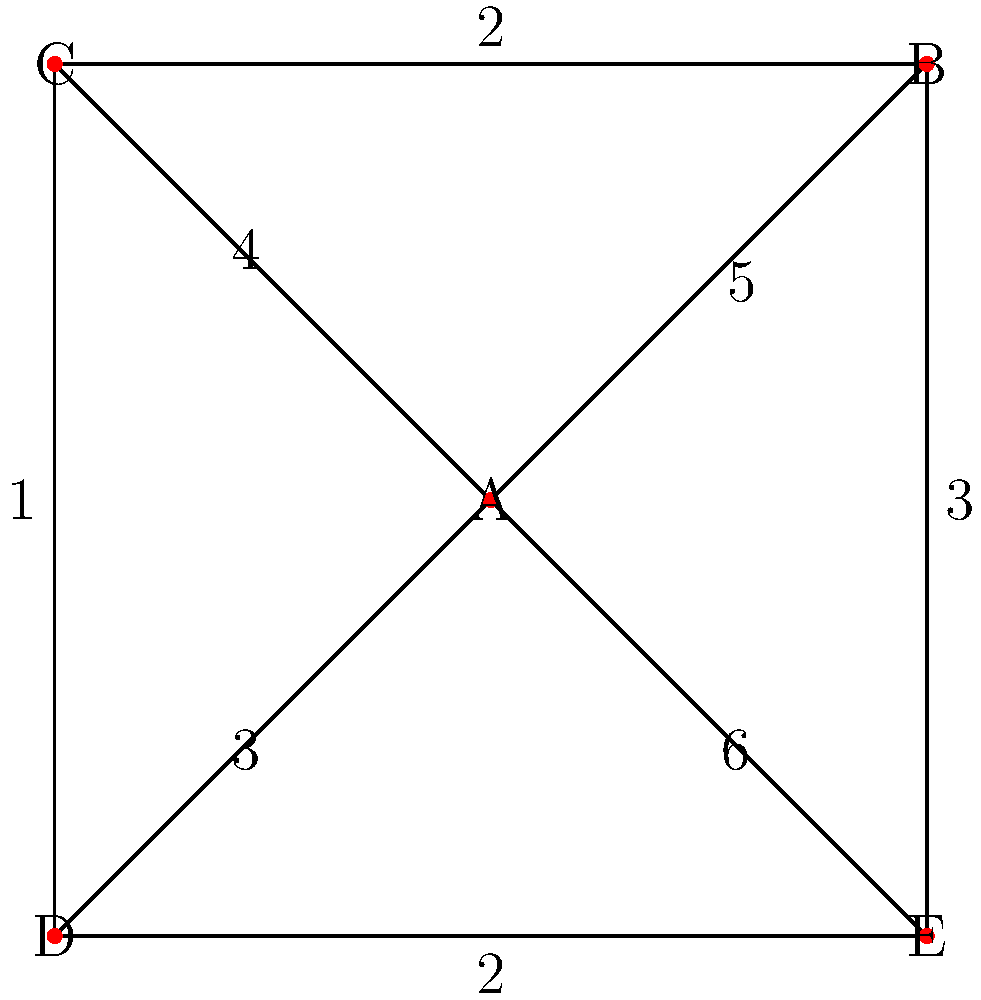As an investor in cultural preservation projects, you are presented with a network of five interconnected initiatives (A, B, C, D, E) represented as nodes in a graph. The edges between nodes represent potential synergies, with weights indicating the strength of these synergies on a scale of 1-6. You have a budget to fund three projects. Which combination of three projects should you choose to maximize the total synergy between them? To solve this problem, we need to follow these steps:

1. Identify all possible combinations of three projects.
2. Calculate the total synergy for each combination.
3. Choose the combination with the highest total synergy.

Step 1: Possible combinations of three projects:
- A, B, C
- A, B, D
- A, B, E
- A, C, D
- A, C, E
- A, D, E
- B, C, D
- B, C, E
- B, D, E
- C, D, E

Step 2: Calculate total synergy for each combination:
- A, B, C: 5 + 4 + 2 = 11
- A, B, D: 5 + 3 = 8
- A, B, E: 5 + 6 + 3 = 14
- A, C, D: 4 + 3 + 1 = 8
- A, C, E: 4 + 6 = 10
- A, D, E: 3 + 6 + 2 = 11
- B, C, D: 2 + 1 = 3
- B, C, E: 2 + 3 = 5
- B, D, E: 3 + 2 = 5
- C, D, E: 1 + 2 = 3

Step 3: The combination with the highest total synergy is A, B, E with a total synergy of 14.
Answer: Projects A, B, and E 